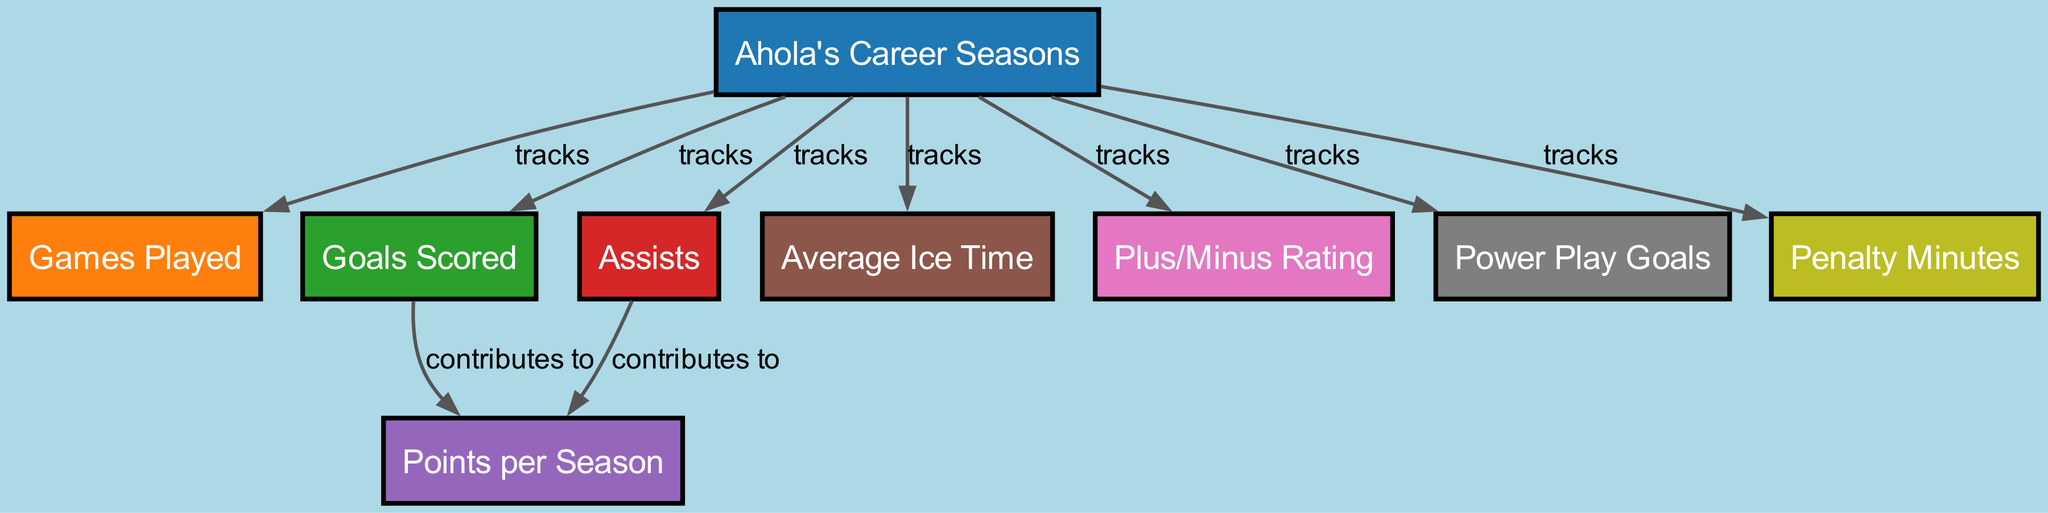What is the total number of seasons Ahola played? The diagram contains a node labeled "Ahola's Career Seasons," which represents the total number of seasons he played. This node directly corresponds to the overall count of his career seasons.
Answer: Total of seasons What metric tracks the total number of games played each season? The diagram shows an edge labeled "tracks" from "Ahola's Career Seasons" to "Games Played," indicating that "Games Played" is the metric that follows the number of games played each season.
Answer: Games Played Which statistic contributes to points scored? The diagram indicates that both "Goals Scored" and "Assists" contribute to "Points per Season." There are directed edges labeled "contributes to" from both "Goals Scored" and "Assists" to "Points per Season."
Answer: Goals Scored and Assists What is the relationship between average ice time and games played? The diagram has an edge showing that both "Average Ice Time" and "Games Played" are tracked in connection with "Ahola's Career Seasons." However, no direct contribution relationship is illustrated, meaning they are separate metrics.
Answer: No direct relationship What are the total penalty minutes tracked each season? The diagram indicates that "Penalty Minutes" is tracked directly from "Ahola's Career Seasons" denoting that all penalty minutes for each season are monitored separately.
Answer: Total penalty minutes How does the average ice time relate to goals scored? In the diagram, "Average Ice Time" and "Goals Scored" both have edges from "Ahola's Career Seasons," but there is no direct contributing relationship between the two. Therefore, they do not connect in contributing to each other.
Answer: Not related What is the Plus/Minus rating tracking? The diagram indicates that "Plus/Minus Rating" is also tracked from "Ahola's Career Seasons." This suggests that it is another metric independently monitored without direct contributions from the other statistics.
Answer: Plus/Minus Rating 